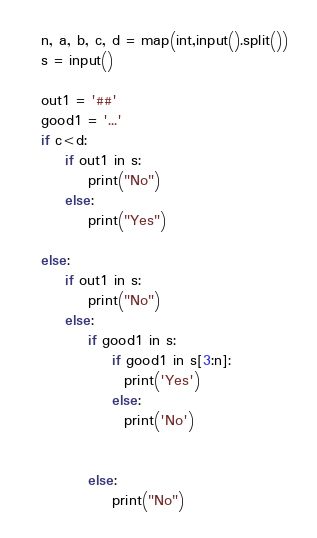Convert code to text. <code><loc_0><loc_0><loc_500><loc_500><_Python_>n, a, b, c, d = map(int,input().split())
s = input()

out1 = '##'
good1 = '...'
if c<d:
    if out1 in s:
        print("No")
    else:
        print("Yes")

else:
    if out1 in s:
        print("No")
    else:
        if good1 in s:
            if good1 in s[3:n]:
              print('Yes')
            else:
              print('No')
              
            
        else:
            print("No")</code> 